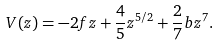Convert formula to latex. <formula><loc_0><loc_0><loc_500><loc_500>V ( z ) = - 2 f z + \frac { 4 } { 5 } z ^ { 5 / 2 } + \frac { 2 } { 7 } b z ^ { 7 } .</formula> 